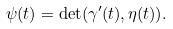<formula> <loc_0><loc_0><loc_500><loc_500>\psi ( t ) = \det ( \gamma ^ { \prime } ( t ) , \eta ( t ) ) .</formula> 